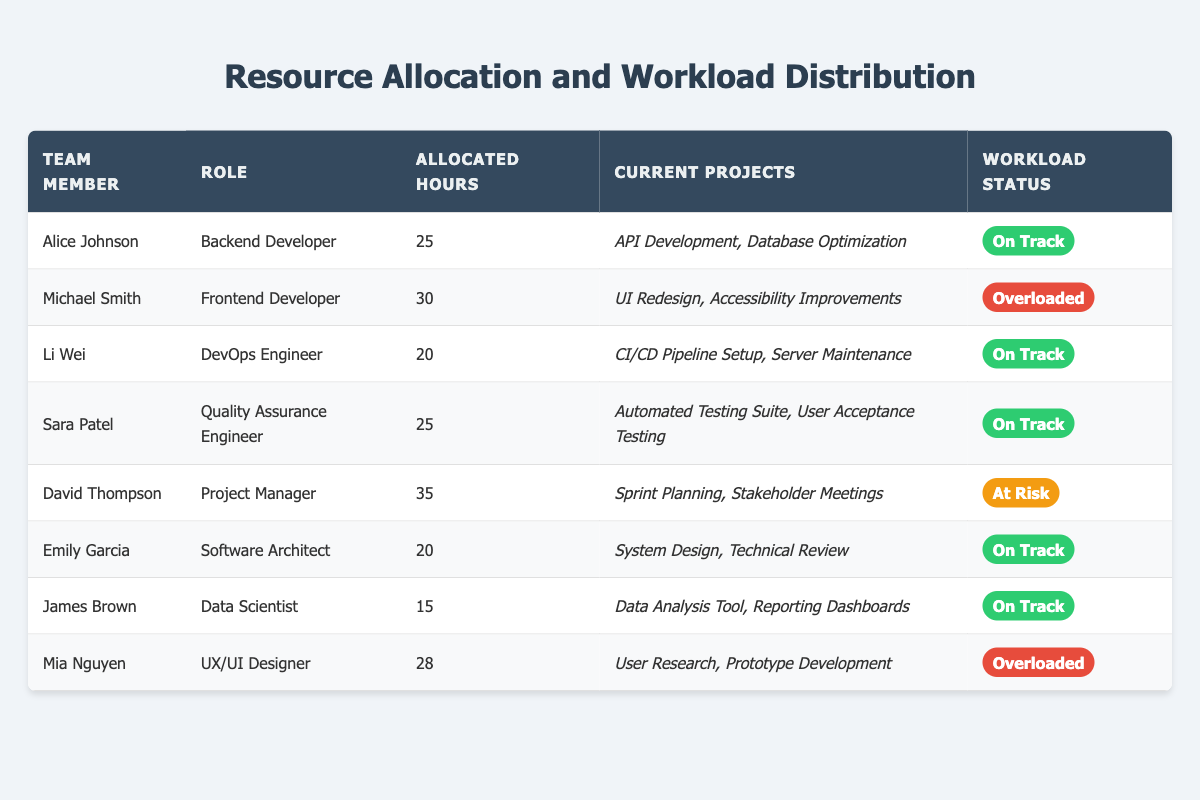What is the workload status of Alice Johnson? Alice Johnson's workload status is mentioned directly in the table under the "Workload Status" column, which states "On Track."
Answer: On Track How many hours are allocated to Michael Smith? The table shows that Michael Smith has 30 hours allocated, which is clearly stated in the "Allocated Hours" column.
Answer: 30 Which team member is overloaded? According to the "Workload Status" column, both Michael Smith and Mia Nguyen are marked as "Overloaded."
Answer: Michael Smith and Mia Nguyen What is the total number of allocated hours for all team members? Adding the allocated hours: 25 (Alice) + 30 (Michael) + 20 (Li) + 25 (Sara) + 35 (David) + 20 (Emily) + 15 (James) + 28 (Mia) gives a total of 25 + 30 + 20 + 25 + 35 + 20 + 15 + 28 =  28 + 50 + 35 + 20 + 25 =  30 + 25 + 50 =  157
Answer: 157 How many team members have "On Track" as their workload status? The table lists four team members with "On Track" status: Alice Johnson, Li Wei, Sara Patel, and Emily Garcia. Hence, the count is 4.
Answer: 4 Is any team member both a Backend Developer and “At Risk”? The table shows Alice Johnson as a Backend Developer with the status "On Track" and David Thompson as a Project Manager with the status "At Risk." Thus, no team member fits both criteria.
Answer: No Which role has the highest allocated hours? By examining the "Allocated Hours" column, David Thompson (Project Manager) has the highest allocation at 35 hours compared to others.
Answer: Project Manager How many hours are allocated to team members whose workload status is "Overloaded"? The workloads of Michael Smith and Mia Nguyen are "Overloaded." Their allocated hours are 30 and 28 respectively: 30 + 28 = 58.
Answer: 58 What percentage of total allocated hours is assigned to the Project Manager? The project manager's hours (35) out of the total hours (157). Calculate: (35 / 157) * 100 ≈ 22.29%.
Answer: 22.29% Who is the Software Architect? According to the table, Emily Garcia holds the title of Software Architect under the "Role" column.
Answer: Emily Garcia How many team members are both Frontend Developers or DevOps Engineers? Only one member (Michael Smith) is a Frontend Developer and one member (Li Wei) is a DevOps Engineer. Summing them gives: 1 + 1 = 2.
Answer: 2 Which team member has the least allocated hours? The table indicates that James Brown, the Data Scientist, has the least allocated hours at 15.
Answer: James Brown 